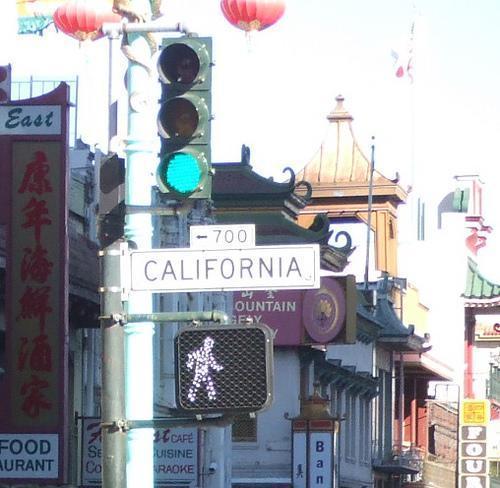How many people are using a cell phone in the image?
Give a very brief answer. 0. 